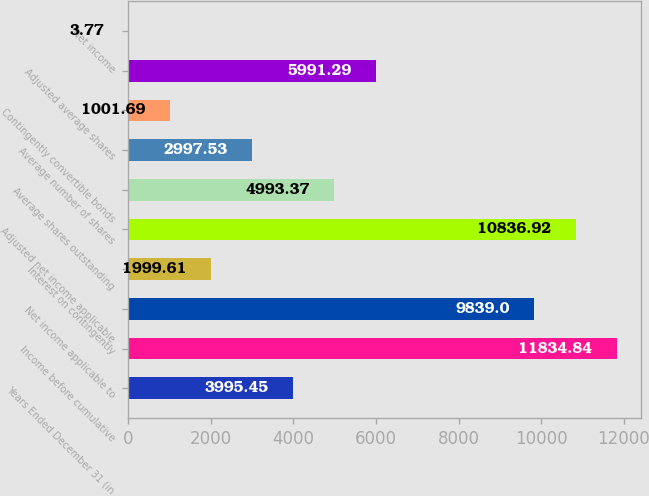<chart> <loc_0><loc_0><loc_500><loc_500><bar_chart><fcel>Years Ended December 31 (in<fcel>Income before cumulative<fcel>Net income applicable to<fcel>Interest on contingently<fcel>Adjusted net income applicable<fcel>Average shares outstanding<fcel>Average number of shares<fcel>Contingently convertible bonds<fcel>Adjusted average shares<fcel>Net income<nl><fcel>3995.45<fcel>11834.8<fcel>9839<fcel>1999.61<fcel>10836.9<fcel>4993.37<fcel>2997.53<fcel>1001.69<fcel>5991.29<fcel>3.77<nl></chart> 